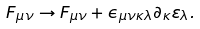Convert formula to latex. <formula><loc_0><loc_0><loc_500><loc_500>F _ { \mu \nu } \to F _ { \mu \nu } + \epsilon _ { \mu \nu \kappa \lambda } \partial _ { \kappa } \varepsilon _ { \lambda } .</formula> 